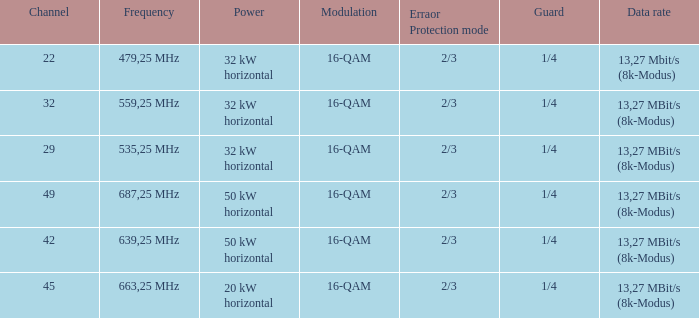On channel 32, when the power is 32 kw in the horizontal direction, what is the modulation? 16-QAM. 